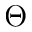Convert formula to latex. <formula><loc_0><loc_0><loc_500><loc_500>\Theta</formula> 